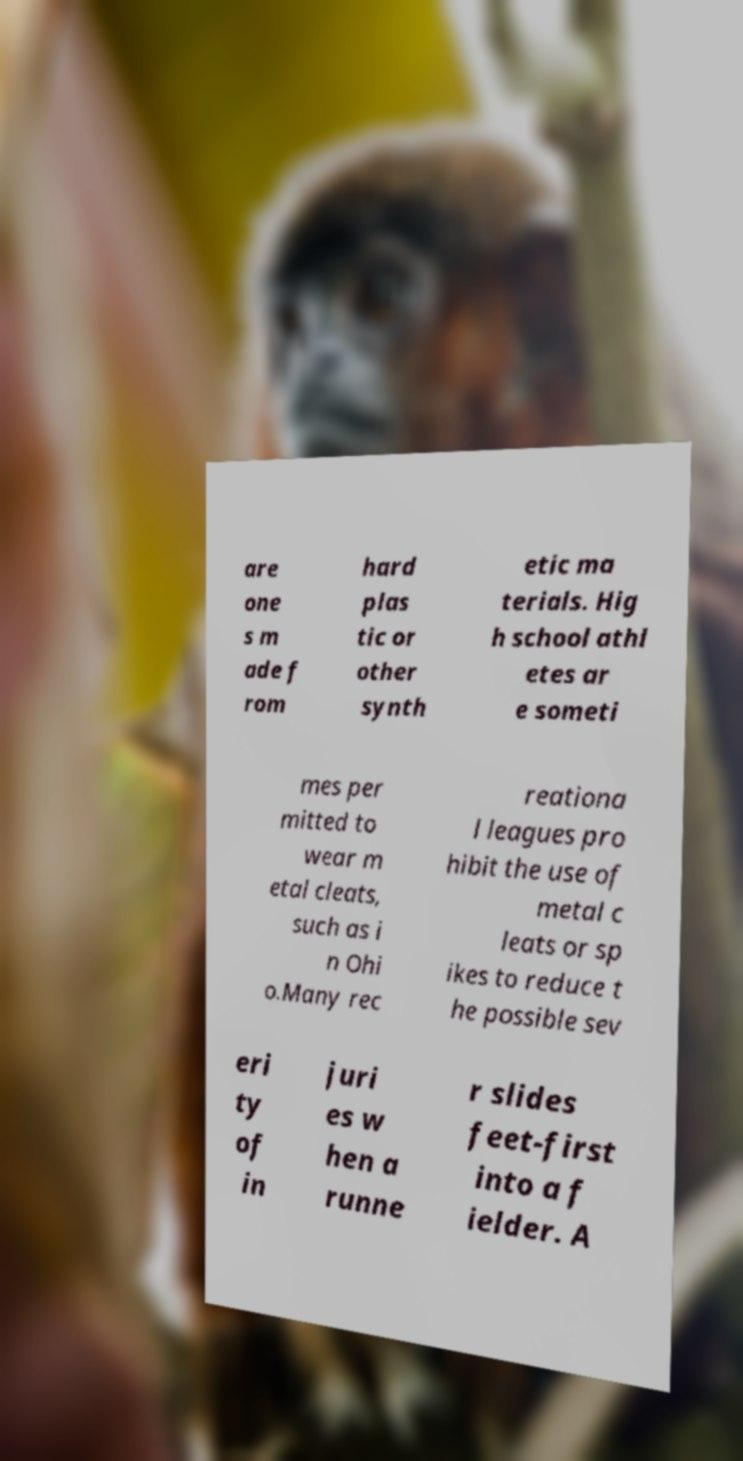For documentation purposes, I need the text within this image transcribed. Could you provide that? are one s m ade f rom hard plas tic or other synth etic ma terials. Hig h school athl etes ar e someti mes per mitted to wear m etal cleats, such as i n Ohi o.Many rec reationa l leagues pro hibit the use of metal c leats or sp ikes to reduce t he possible sev eri ty of in juri es w hen a runne r slides feet-first into a f ielder. A 